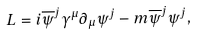Convert formula to latex. <formula><loc_0><loc_0><loc_500><loc_500>L = i \overline { \psi } ^ { j } \gamma ^ { \mu } \partial _ { \mu } \psi ^ { j } - m \overline { \psi } ^ { j } \psi ^ { j } ,</formula> 